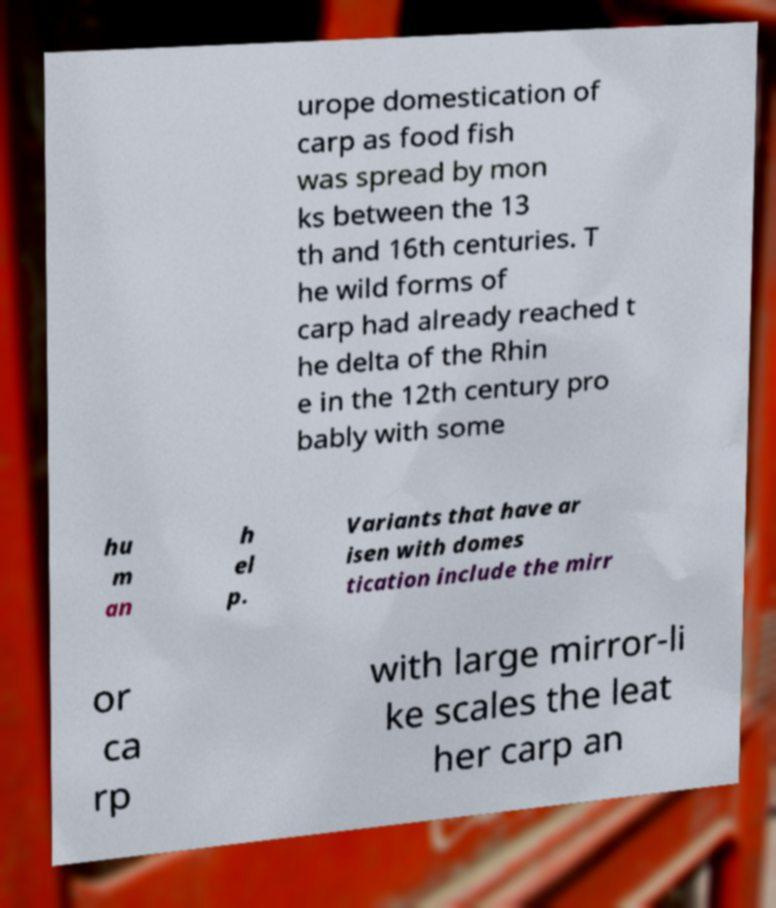There's text embedded in this image that I need extracted. Can you transcribe it verbatim? urope domestication of carp as food fish was spread by mon ks between the 13 th and 16th centuries. T he wild forms of carp had already reached t he delta of the Rhin e in the 12th century pro bably with some hu m an h el p. Variants that have ar isen with domes tication include the mirr or ca rp with large mirror-li ke scales the leat her carp an 